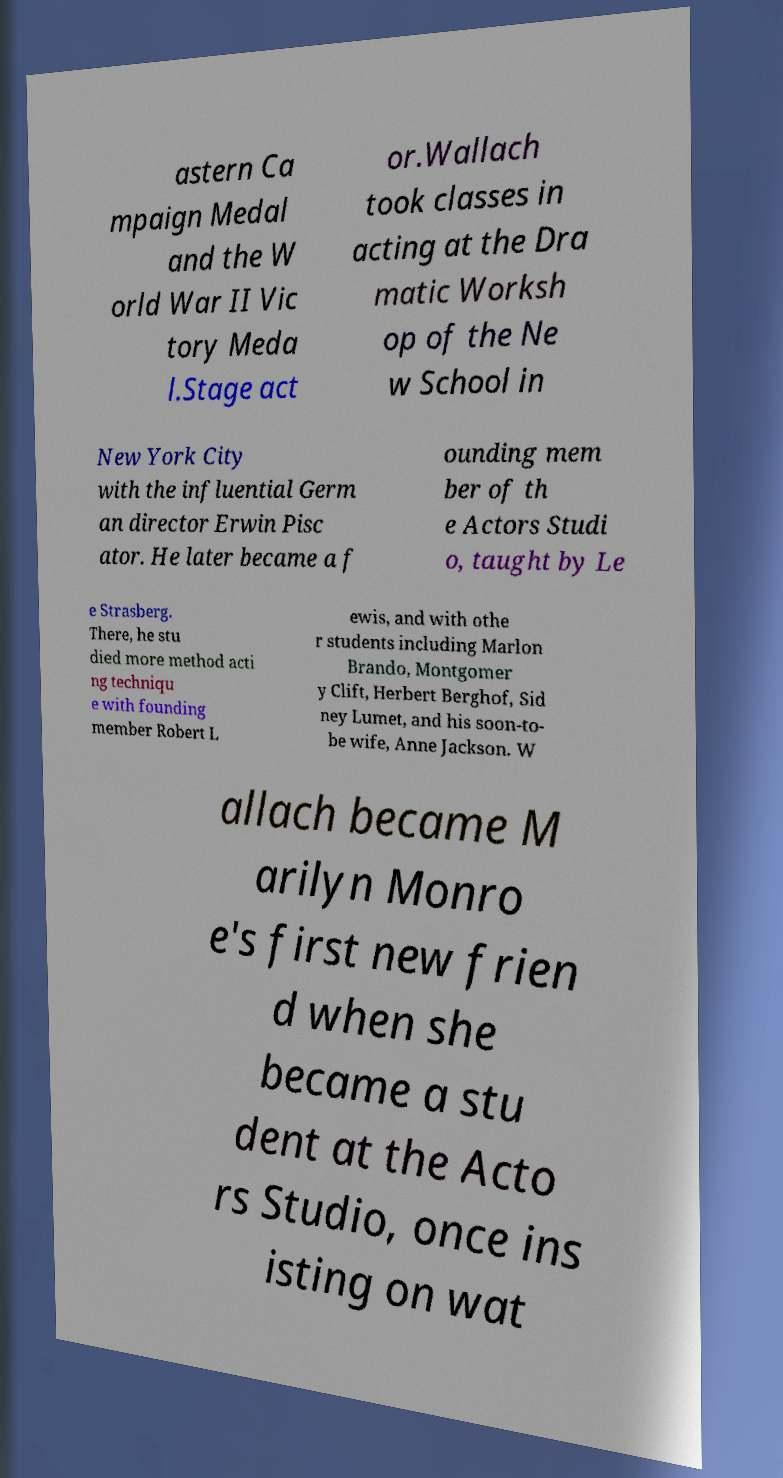Could you extract and type out the text from this image? astern Ca mpaign Medal and the W orld War II Vic tory Meda l.Stage act or.Wallach took classes in acting at the Dra matic Worksh op of the Ne w School in New York City with the influential Germ an director Erwin Pisc ator. He later became a f ounding mem ber of th e Actors Studi o, taught by Le e Strasberg. There, he stu died more method acti ng techniqu e with founding member Robert L ewis, and with othe r students including Marlon Brando, Montgomer y Clift, Herbert Berghof, Sid ney Lumet, and his soon-to- be wife, Anne Jackson. W allach became M arilyn Monro e's first new frien d when she became a stu dent at the Acto rs Studio, once ins isting on wat 